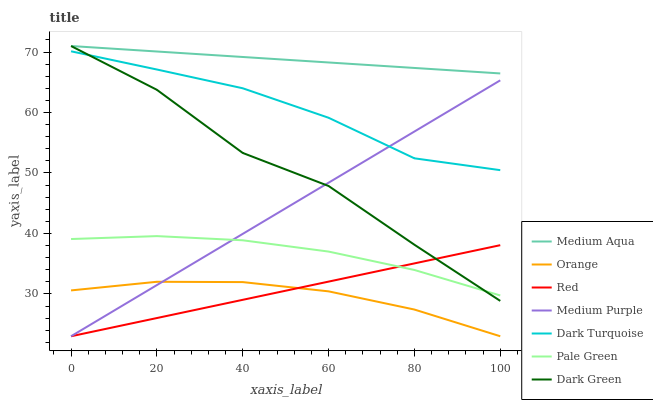Does Orange have the minimum area under the curve?
Answer yes or no. Yes. Does Medium Aqua have the maximum area under the curve?
Answer yes or no. Yes. Does Medium Purple have the minimum area under the curve?
Answer yes or no. No. Does Medium Purple have the maximum area under the curve?
Answer yes or no. No. Is Red the smoothest?
Answer yes or no. Yes. Is Dark Green the roughest?
Answer yes or no. Yes. Is Medium Purple the smoothest?
Answer yes or no. No. Is Medium Purple the roughest?
Answer yes or no. No. Does Medium Purple have the lowest value?
Answer yes or no. Yes. Does Pale Green have the lowest value?
Answer yes or no. No. Does Dark Green have the highest value?
Answer yes or no. Yes. Does Medium Purple have the highest value?
Answer yes or no. No. Is Orange less than Dark Green?
Answer yes or no. Yes. Is Medium Aqua greater than Pale Green?
Answer yes or no. Yes. Does Dark Green intersect Dark Turquoise?
Answer yes or no. Yes. Is Dark Green less than Dark Turquoise?
Answer yes or no. No. Is Dark Green greater than Dark Turquoise?
Answer yes or no. No. Does Orange intersect Dark Green?
Answer yes or no. No. 